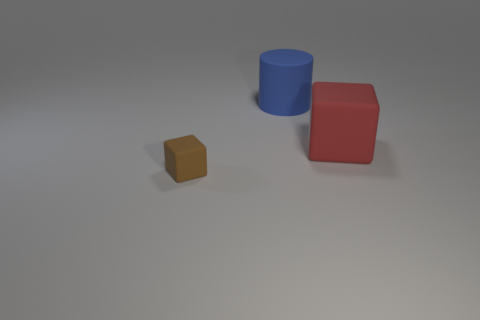If I were to move the red cube closer to the blue cylinder, would their shadows overlap? Given the current positions of the shadows, if you move the red cube closer to the blue cylinder, their shadows would likely begin to overlap because the light source is to the left and the shadows extend to the right. 